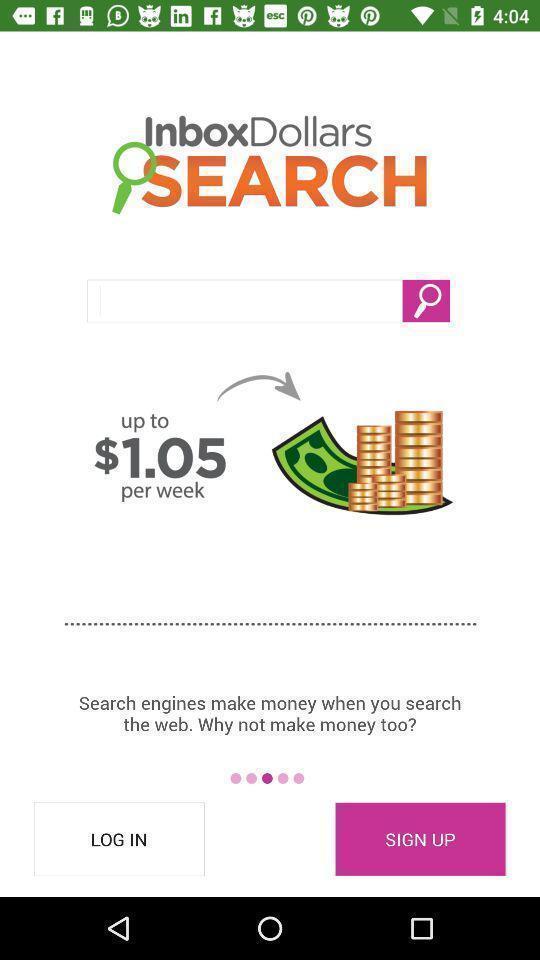Provide a textual representation of this image. Welcome page for money making app with information. 